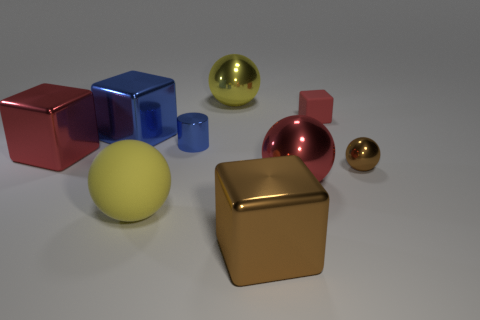Is there anything else that is the same size as the red shiny sphere?
Your response must be concise. Yes. The red rubber cube is what size?
Ensure brevity in your answer.  Small. What number of tiny things are either rubber spheres or purple metallic cylinders?
Provide a succinct answer. 0. There is a red metal sphere; does it have the same size as the brown metallic cube in front of the red matte object?
Provide a short and direct response. Yes. Are there any other things that have the same shape as the large yellow shiny object?
Your response must be concise. Yes. What number of big yellow matte objects are there?
Give a very brief answer. 1. What number of purple objects are either blocks or big metal objects?
Give a very brief answer. 0. Are the large yellow thing behind the tiny brown thing and the small brown thing made of the same material?
Ensure brevity in your answer.  Yes. How many other things are the same material as the big blue object?
Keep it short and to the point. 6. What is the material of the small brown object?
Offer a terse response. Metal. 